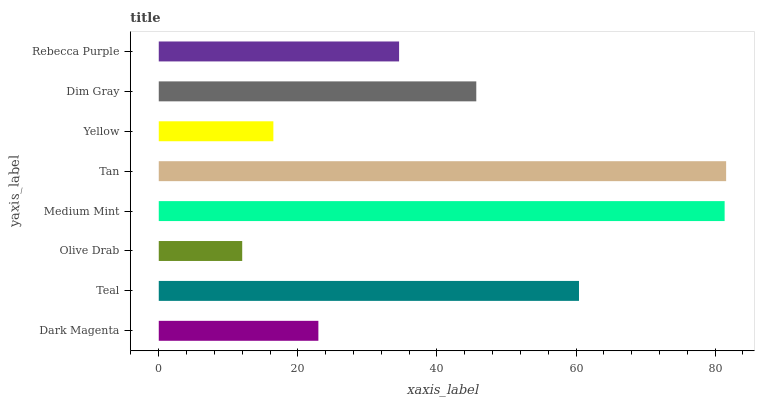Is Olive Drab the minimum?
Answer yes or no. Yes. Is Tan the maximum?
Answer yes or no. Yes. Is Teal the minimum?
Answer yes or no. No. Is Teal the maximum?
Answer yes or no. No. Is Teal greater than Dark Magenta?
Answer yes or no. Yes. Is Dark Magenta less than Teal?
Answer yes or no. Yes. Is Dark Magenta greater than Teal?
Answer yes or no. No. Is Teal less than Dark Magenta?
Answer yes or no. No. Is Dim Gray the high median?
Answer yes or no. Yes. Is Rebecca Purple the low median?
Answer yes or no. Yes. Is Yellow the high median?
Answer yes or no. No. Is Tan the low median?
Answer yes or no. No. 